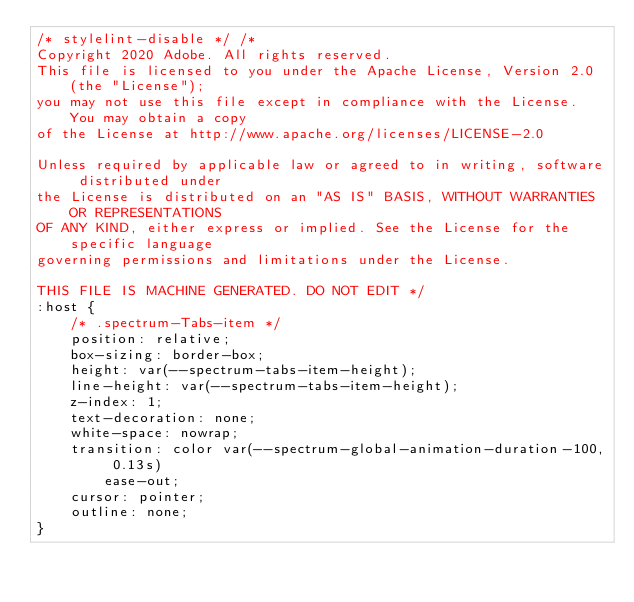<code> <loc_0><loc_0><loc_500><loc_500><_CSS_>/* stylelint-disable */ /* 
Copyright 2020 Adobe. All rights reserved.
This file is licensed to you under the Apache License, Version 2.0 (the "License");
you may not use this file except in compliance with the License. You may obtain a copy
of the License at http://www.apache.org/licenses/LICENSE-2.0

Unless required by applicable law or agreed to in writing, software distributed under
the License is distributed on an "AS IS" BASIS, WITHOUT WARRANTIES OR REPRESENTATIONS
OF ANY KIND, either express or implied. See the License for the specific language
governing permissions and limitations under the License.

THIS FILE IS MACHINE GENERATED. DO NOT EDIT */
:host {
    /* .spectrum-Tabs-item */
    position: relative;
    box-sizing: border-box;
    height: var(--spectrum-tabs-item-height);
    line-height: var(--spectrum-tabs-item-height);
    z-index: 1;
    text-decoration: none;
    white-space: nowrap;
    transition: color var(--spectrum-global-animation-duration-100, 0.13s)
        ease-out;
    cursor: pointer;
    outline: none;
}</code> 